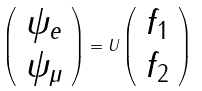<formula> <loc_0><loc_0><loc_500><loc_500>\left ( \begin{array} { c } \psi _ { e } \\ \psi _ { \mu } \end{array} \right ) = U \left ( \begin{array} { c } f _ { 1 } \\ f _ { 2 } \end{array} \right )</formula> 